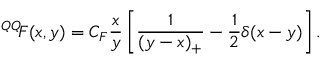<formula> <loc_0><loc_0><loc_500><loc_500>{ ^ { Q Q } \, F } ( x , y ) = C _ { F } \frac { x } { y } \left [ \frac { 1 } { ( y - x ) _ { + } } - \frac { 1 } { 2 } \delta ( x - y ) \right ] .</formula> 